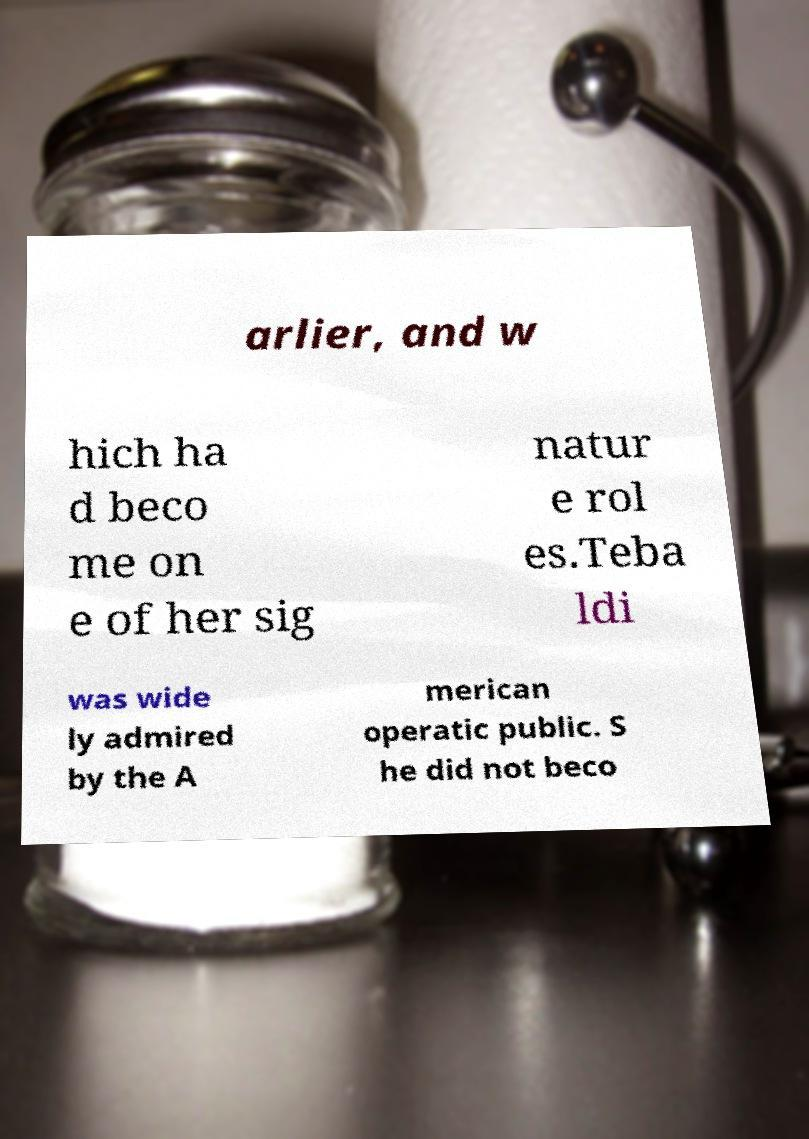There's text embedded in this image that I need extracted. Can you transcribe it verbatim? arlier, and w hich ha d beco me on e of her sig natur e rol es.Teba ldi was wide ly admired by the A merican operatic public. S he did not beco 